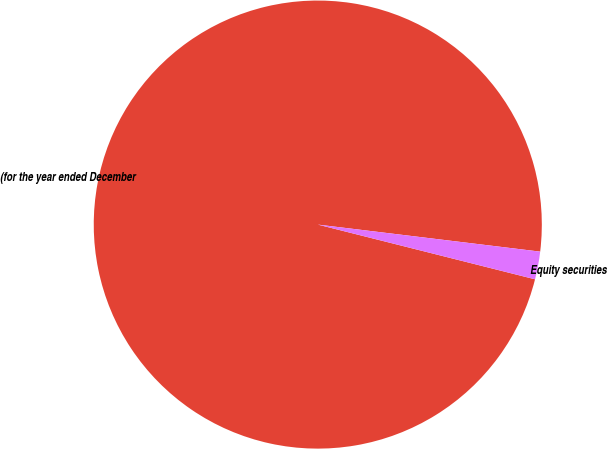Convert chart. <chart><loc_0><loc_0><loc_500><loc_500><pie_chart><fcel>(for the year ended December<fcel>Equity securities<nl><fcel>98.0%<fcel>2.0%<nl></chart> 